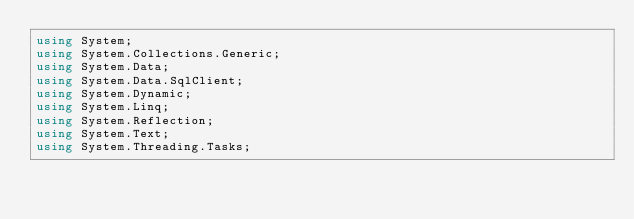<code> <loc_0><loc_0><loc_500><loc_500><_C#_>using System;
using System.Collections.Generic;
using System.Data;
using System.Data.SqlClient;
using System.Dynamic;
using System.Linq;
using System.Reflection;
using System.Text;
using System.Threading.Tasks;</code> 